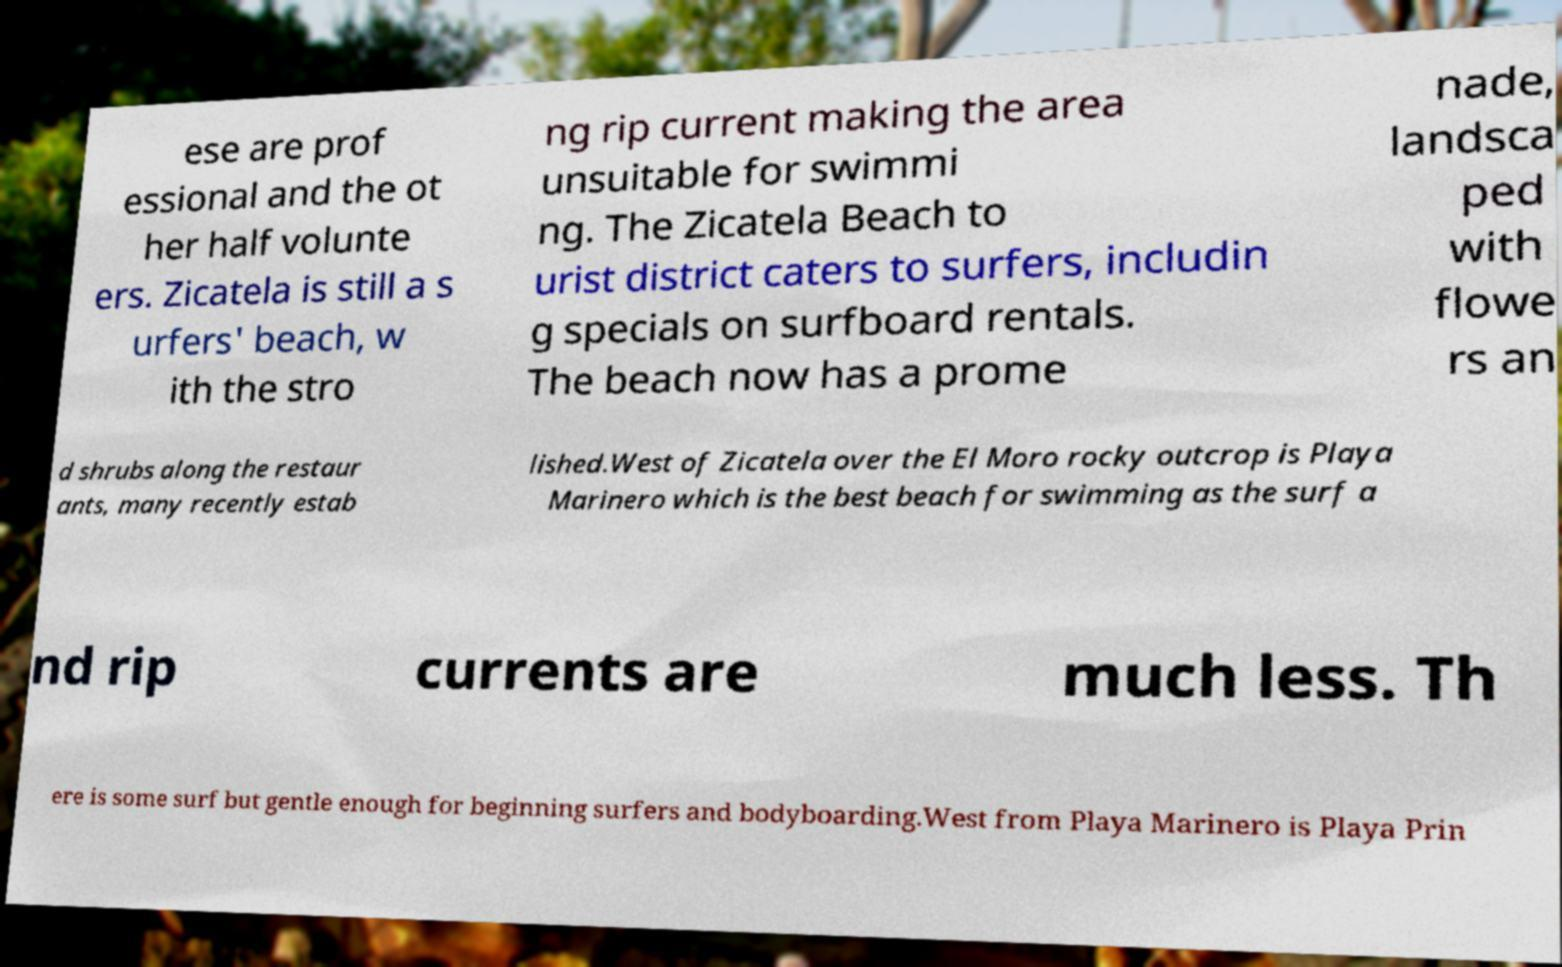Please identify and transcribe the text found in this image. ese are prof essional and the ot her half volunte ers. Zicatela is still a s urfers' beach, w ith the stro ng rip current making the area unsuitable for swimmi ng. The Zicatela Beach to urist district caters to surfers, includin g specials on surfboard rentals. The beach now has a prome nade, landsca ped with flowe rs an d shrubs along the restaur ants, many recently estab lished.West of Zicatela over the El Moro rocky outcrop is Playa Marinero which is the best beach for swimming as the surf a nd rip currents are much less. Th ere is some surf but gentle enough for beginning surfers and bodyboarding.West from Playa Marinero is Playa Prin 